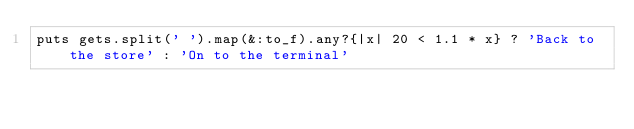<code> <loc_0><loc_0><loc_500><loc_500><_Ruby_>puts gets.split(' ').map(&:to_f).any?{|x| 20 < 1.1 * x} ? 'Back to the store' : 'On to the terminal'
</code> 